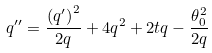Convert formula to latex. <formula><loc_0><loc_0><loc_500><loc_500>q ^ { \prime \prime } = \frac { \left ( q ^ { \prime } \right ) ^ { 2 } } { 2 q } + 4 q ^ { 2 } + 2 t q - \frac { \theta _ { 0 } ^ { 2 } } { 2 q }</formula> 